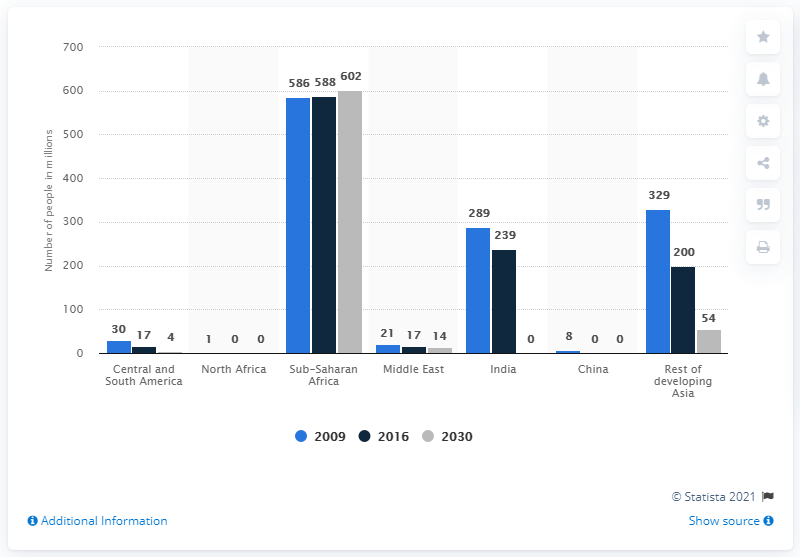Highlight a few significant elements in this photo. In 2016, approximately 586 million people in Sub-Saharan Africa lacked access to electricity. By 2030, an estimated 602 million people in Sub-Saharan Africa will not have access to electricity, highlighting the need for increased efforts to address energy poverty in the region. 